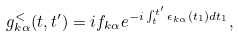<formula> <loc_0><loc_0><loc_500><loc_500>g _ { k \alpha } ^ { < } ( t , t ^ { \prime } ) = i f _ { k \alpha } e ^ { - i \int _ { t } ^ { t ^ { \prime } } \epsilon _ { k \alpha } ( t _ { 1 } ) d t _ { 1 } } ,</formula> 